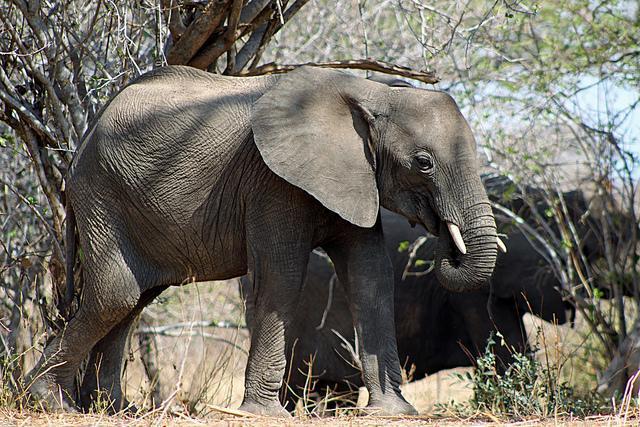How many elephants are there?
Give a very brief answer. 2. How many cars can be seen?
Give a very brief answer. 0. 